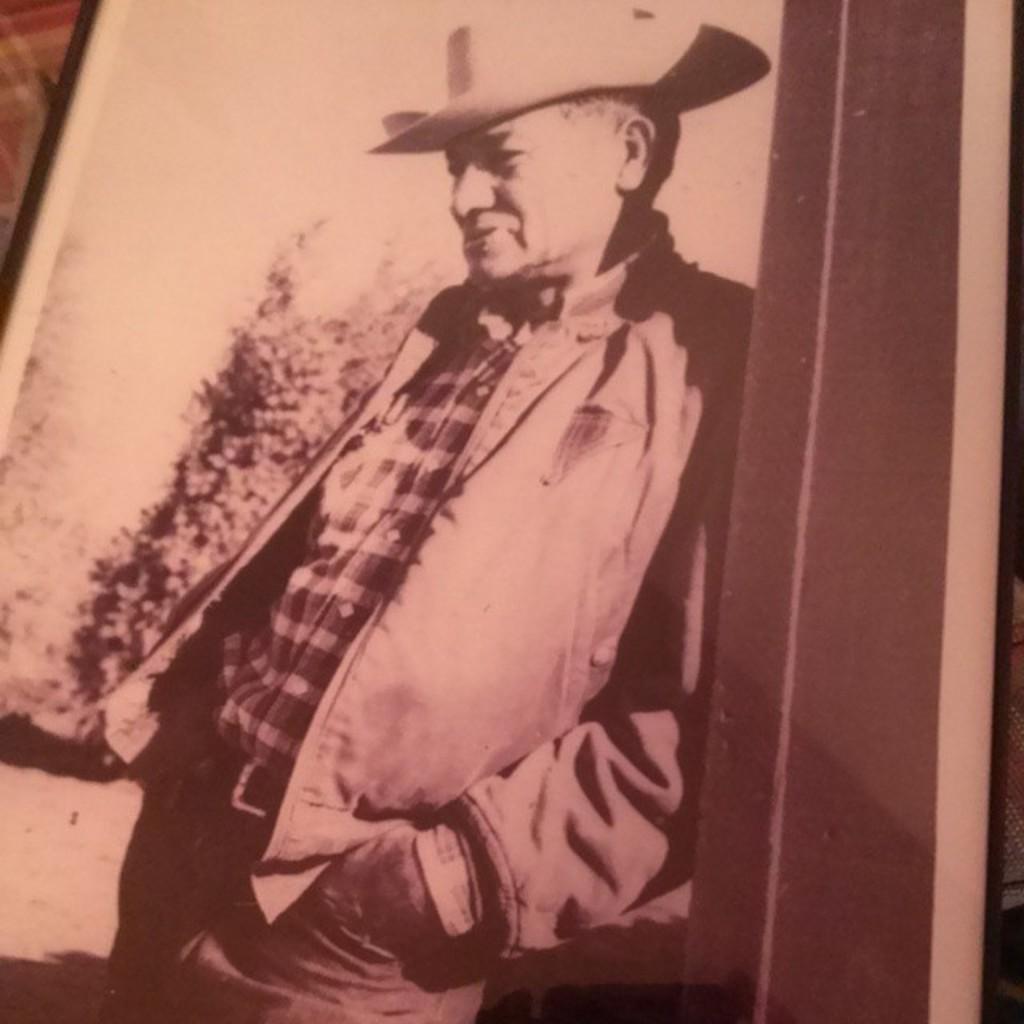How would you summarize this image in a sentence or two? In this image we can see an object which looks like a photo frame and in the photo frame, we can see a person standing and wearing a hat and there is a tree in the background. 